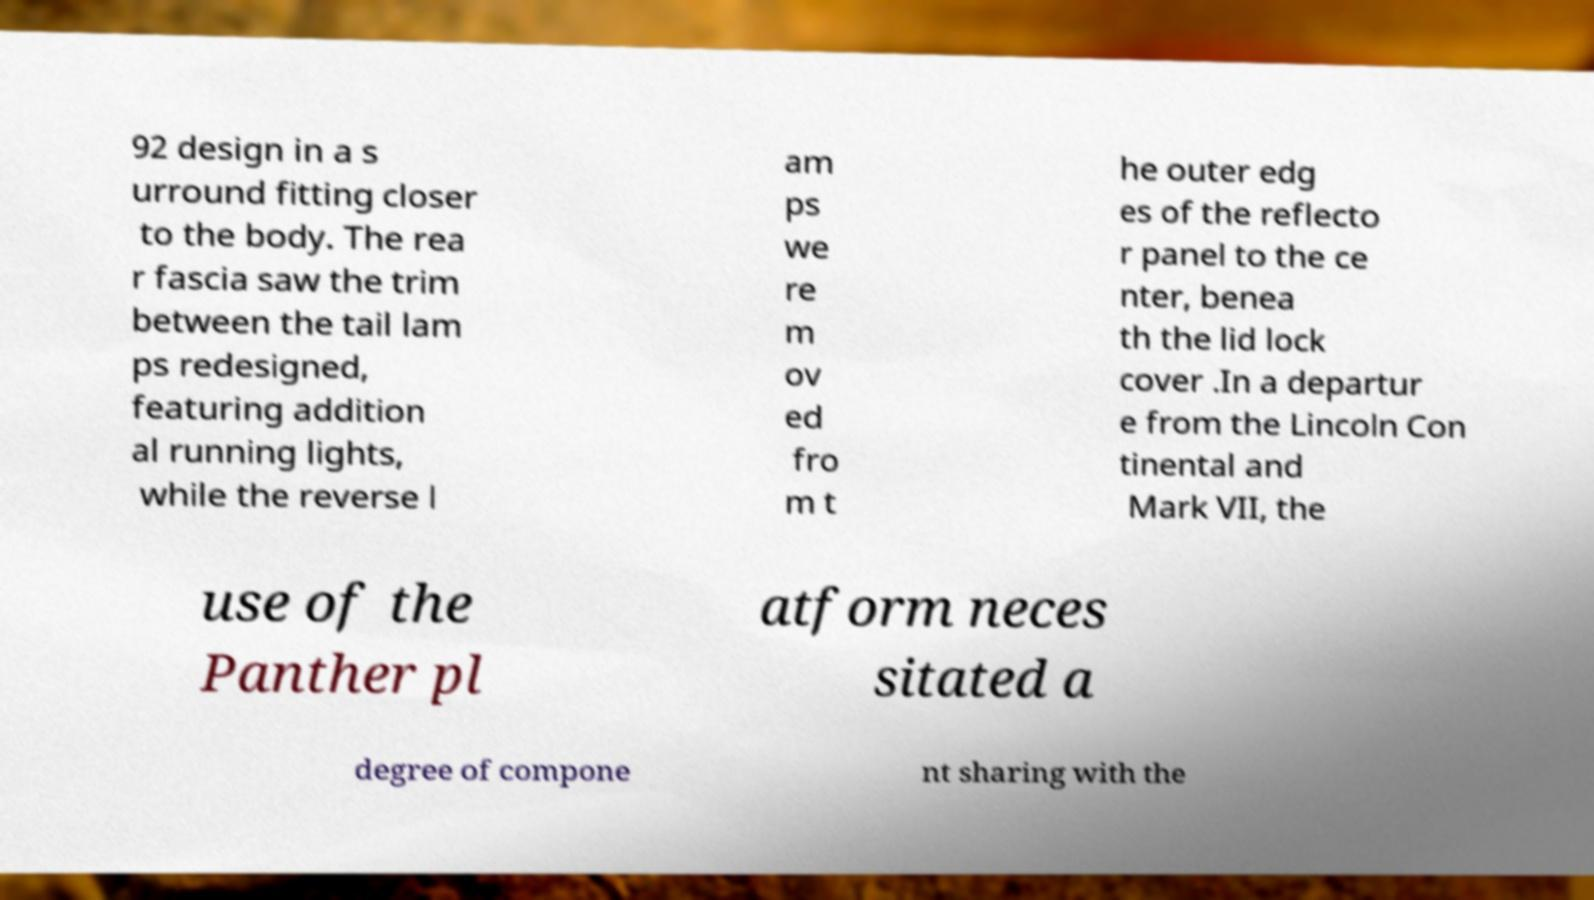Please identify and transcribe the text found in this image. 92 design in a s urround fitting closer to the body. The rea r fascia saw the trim between the tail lam ps redesigned, featuring addition al running lights, while the reverse l am ps we re m ov ed fro m t he outer edg es of the reflecto r panel to the ce nter, benea th the lid lock cover .In a departur e from the Lincoln Con tinental and Mark VII, the use of the Panther pl atform neces sitated a degree of compone nt sharing with the 